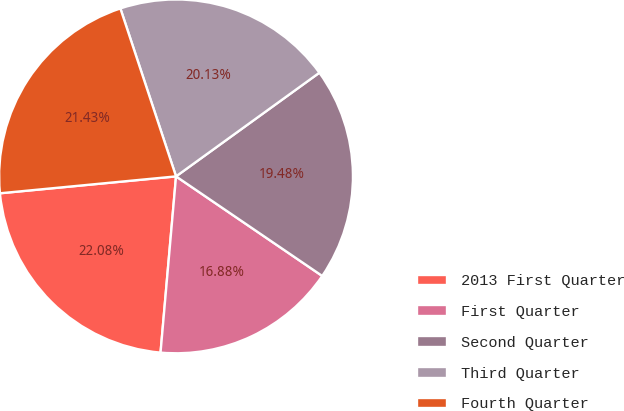<chart> <loc_0><loc_0><loc_500><loc_500><pie_chart><fcel>2013 First Quarter<fcel>First Quarter<fcel>Second Quarter<fcel>Third Quarter<fcel>Fourth Quarter<nl><fcel>22.08%<fcel>16.88%<fcel>19.48%<fcel>20.13%<fcel>21.43%<nl></chart> 